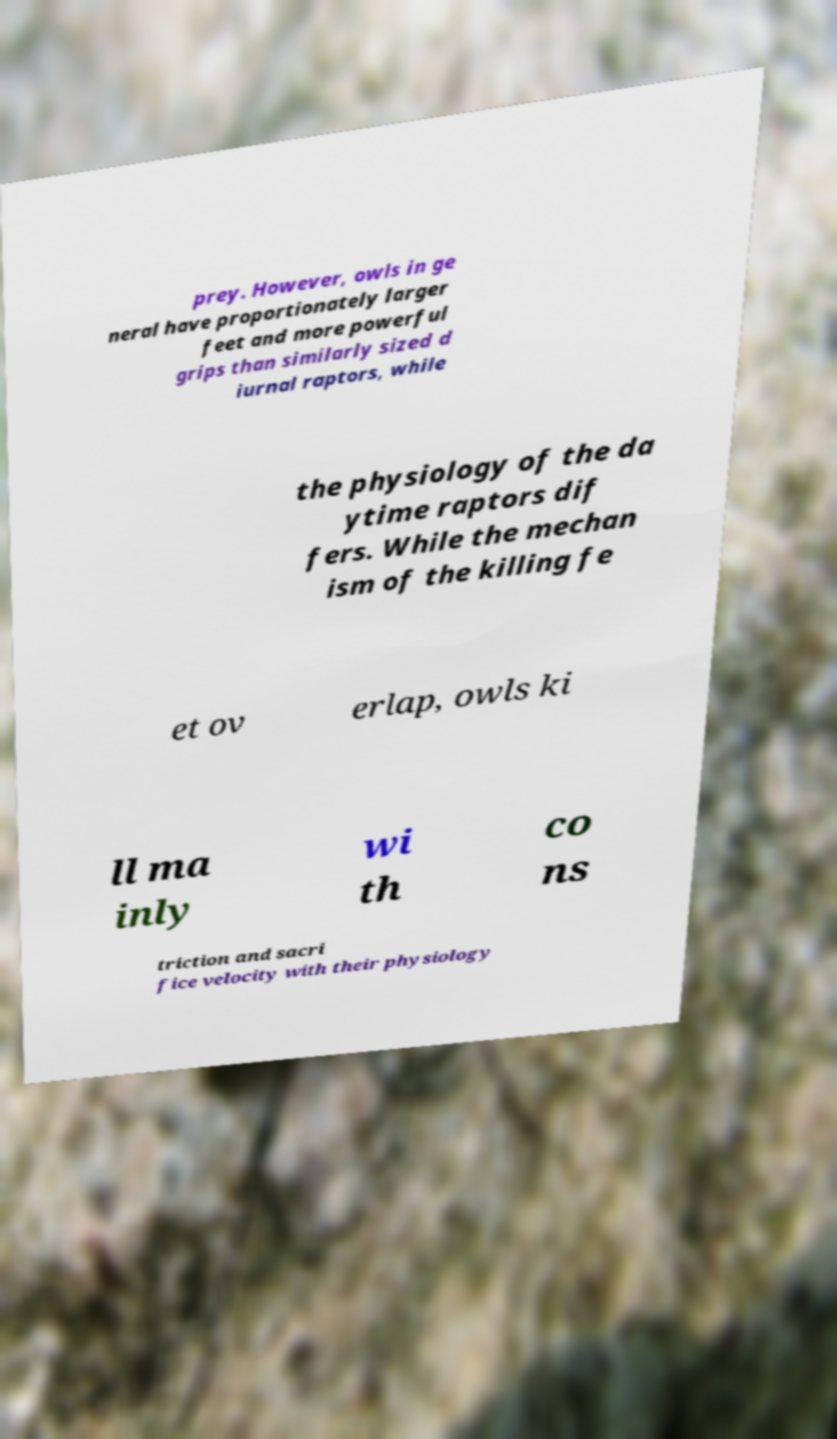Please read and relay the text visible in this image. What does it say? prey. However, owls in ge neral have proportionately larger feet and more powerful grips than similarly sized d iurnal raptors, while the physiology of the da ytime raptors dif fers. While the mechan ism of the killing fe et ov erlap, owls ki ll ma inly wi th co ns triction and sacri fice velocity with their physiology 